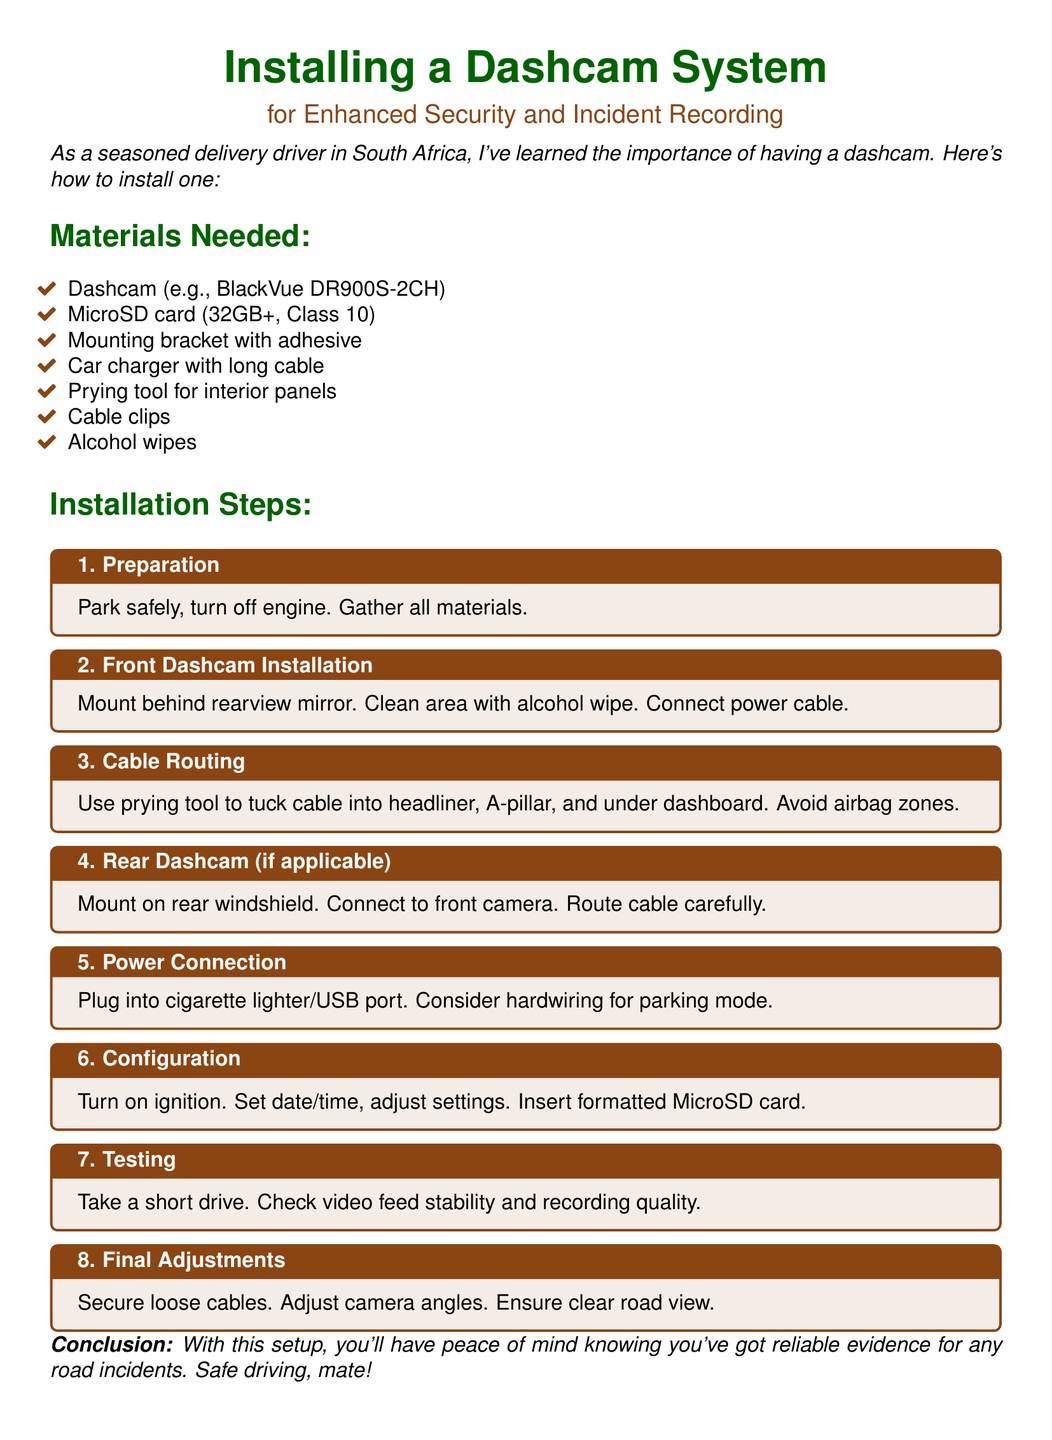What is the title of the document? The title is prominently displayed at the top of the document.
Answer: Installing a Dashcam System What is the required MicroSD card size? The document specifies the size requirement for the MicroSD card in the materials section.
Answer: 32GB+ Which step involves cleaning the installation area? This is mentioned in the instructions for the Front Dashcam Installation step.
Answer: Step 2 How many main steps are there in the installation? The steps are clearly numbered in the installation section of the document.
Answer: 8 What tool is recommended for tucking cables? The document lists this tool in the materials needed.
Answer: Prying tool What should you do during the testing step? This question refers to the actions to be taken in the testing phase of installation.
Answer: Check video feed stability Which part of the vehicle should avoid airbag zones? This is mentioned in relation to cable routing in the installation steps.
Answer: Cable Routing What is the last step in the installation process? The document indicates the final procedure in the sequence of steps.
Answer: Final Adjustments 